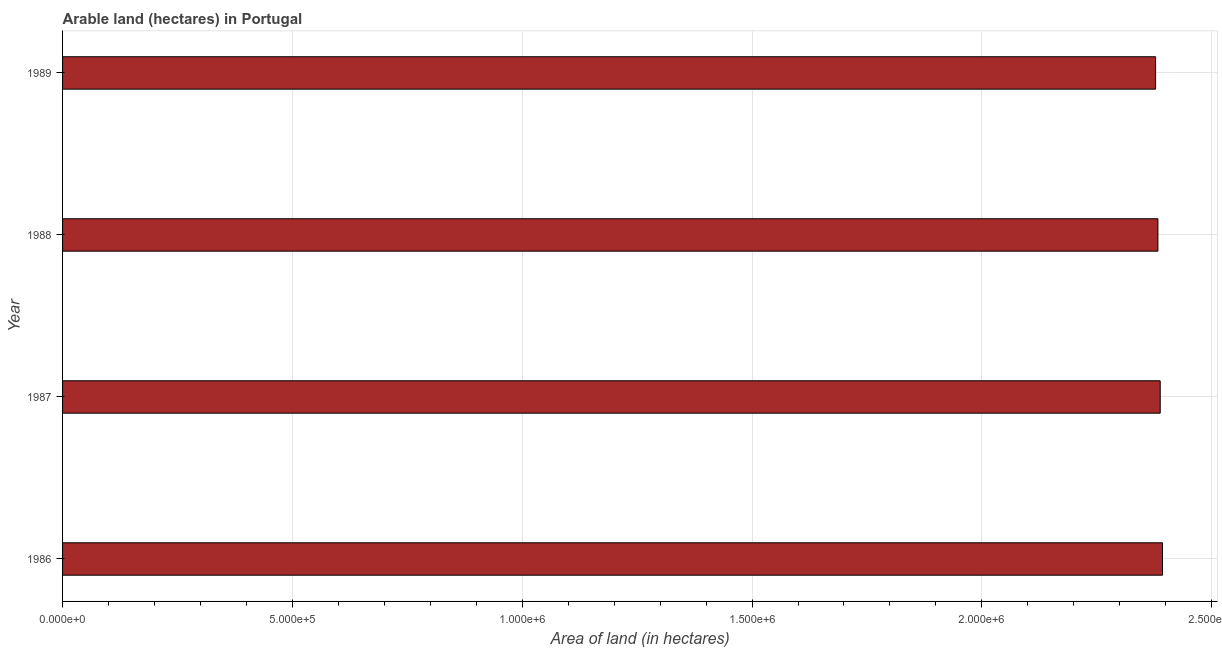What is the title of the graph?
Give a very brief answer. Arable land (hectares) in Portugal. What is the label or title of the X-axis?
Ensure brevity in your answer.  Area of land (in hectares). What is the label or title of the Y-axis?
Keep it short and to the point. Year. What is the area of land in 1988?
Provide a short and direct response. 2.38e+06. Across all years, what is the maximum area of land?
Provide a succinct answer. 2.39e+06. Across all years, what is the minimum area of land?
Your response must be concise. 2.38e+06. In which year was the area of land minimum?
Ensure brevity in your answer.  1989. What is the sum of the area of land?
Provide a succinct answer. 9.54e+06. What is the difference between the area of land in 1988 and 1989?
Offer a terse response. 5000. What is the average area of land per year?
Keep it short and to the point. 2.39e+06. What is the median area of land?
Your response must be concise. 2.39e+06. What is the ratio of the area of land in 1987 to that in 1989?
Give a very brief answer. 1. What is the difference between the highest and the second highest area of land?
Offer a very short reply. 5000. Is the sum of the area of land in 1986 and 1987 greater than the maximum area of land across all years?
Your answer should be compact. Yes. What is the difference between the highest and the lowest area of land?
Offer a very short reply. 1.50e+04. In how many years, is the area of land greater than the average area of land taken over all years?
Make the answer very short. 2. How many bars are there?
Your response must be concise. 4. What is the difference between two consecutive major ticks on the X-axis?
Ensure brevity in your answer.  5.00e+05. Are the values on the major ticks of X-axis written in scientific E-notation?
Provide a succinct answer. Yes. What is the Area of land (in hectares) of 1986?
Your response must be concise. 2.39e+06. What is the Area of land (in hectares) of 1987?
Keep it short and to the point. 2.39e+06. What is the Area of land (in hectares) in 1988?
Give a very brief answer. 2.38e+06. What is the Area of land (in hectares) of 1989?
Your answer should be very brief. 2.38e+06. What is the difference between the Area of land (in hectares) in 1986 and 1988?
Provide a short and direct response. 10000. What is the difference between the Area of land (in hectares) in 1986 and 1989?
Give a very brief answer. 1.50e+04. What is the difference between the Area of land (in hectares) in 1987 and 1988?
Make the answer very short. 5000. What is the ratio of the Area of land (in hectares) in 1986 to that in 1988?
Give a very brief answer. 1. What is the ratio of the Area of land (in hectares) in 1988 to that in 1989?
Ensure brevity in your answer.  1. 